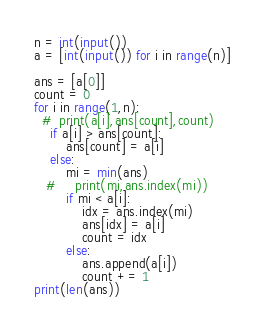<code> <loc_0><loc_0><loc_500><loc_500><_Python_>n = int(input())
a = [int(input()) for i in range(n)]

ans = [a[0]]
count = 0
for i in range(1,n):
  #  print(a[i],ans[count],count)
    if a[i] > ans[count]:
        ans[count] = a[i]
    else:
        mi = min(ans)
   #     print(mi,ans.index(mi))
        if mi < a[i]:
            idx = ans.index(mi)
            ans[idx] = a[i]
            count = idx
        else:
            ans.append(a[i])
            count += 1
print(len(ans))</code> 